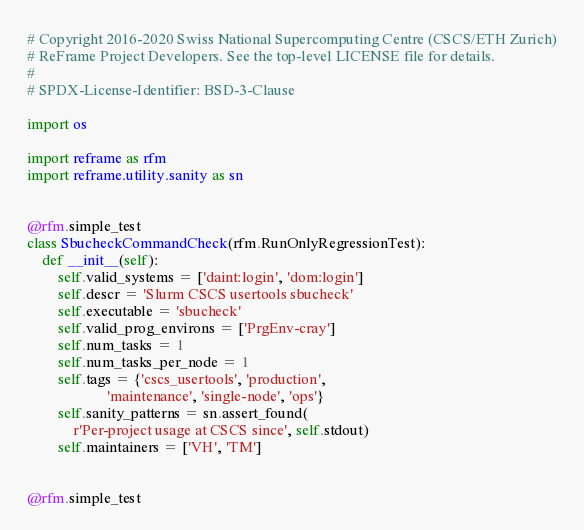Convert code to text. <code><loc_0><loc_0><loc_500><loc_500><_Python_># Copyright 2016-2020 Swiss National Supercomputing Centre (CSCS/ETH Zurich)
# ReFrame Project Developers. See the top-level LICENSE file for details.
#
# SPDX-License-Identifier: BSD-3-Clause

import os

import reframe as rfm
import reframe.utility.sanity as sn


@rfm.simple_test
class SbucheckCommandCheck(rfm.RunOnlyRegressionTest):
    def __init__(self):
        self.valid_systems = ['daint:login', 'dom:login']
        self.descr = 'Slurm CSCS usertools sbucheck'
        self.executable = 'sbucheck'
        self.valid_prog_environs = ['PrgEnv-cray']
        self.num_tasks = 1
        self.num_tasks_per_node = 1
        self.tags = {'cscs_usertools', 'production',
                     'maintenance', 'single-node', 'ops'}
        self.sanity_patterns = sn.assert_found(
            r'Per-project usage at CSCS since', self.stdout)
        self.maintainers = ['VH', 'TM']


@rfm.simple_test</code> 